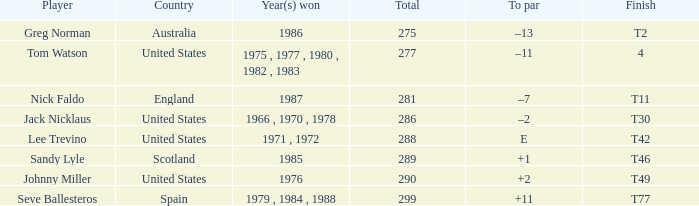What country had a finish of t42? United States. Give me the full table as a dictionary. {'header': ['Player', 'Country', 'Year(s) won', 'Total', 'To par', 'Finish'], 'rows': [['Greg Norman', 'Australia', '1986', '275', '–13', 'T2'], ['Tom Watson', 'United States', '1975 , 1977 , 1980 , 1982 , 1983', '277', '–11', '4'], ['Nick Faldo', 'England', '1987', '281', '–7', 'T11'], ['Jack Nicklaus', 'United States', '1966 , 1970 , 1978', '286', '–2', 'T30'], ['Lee Trevino', 'United States', '1971 , 1972', '288', 'E', 'T42'], ['Sandy Lyle', 'Scotland', '1985', '289', '+1', 'T46'], ['Johnny Miller', 'United States', '1976', '290', '+2', 'T49'], ['Seve Ballesteros', 'Spain', '1979 , 1984 , 1988', '299', '+11', 'T77']]} 